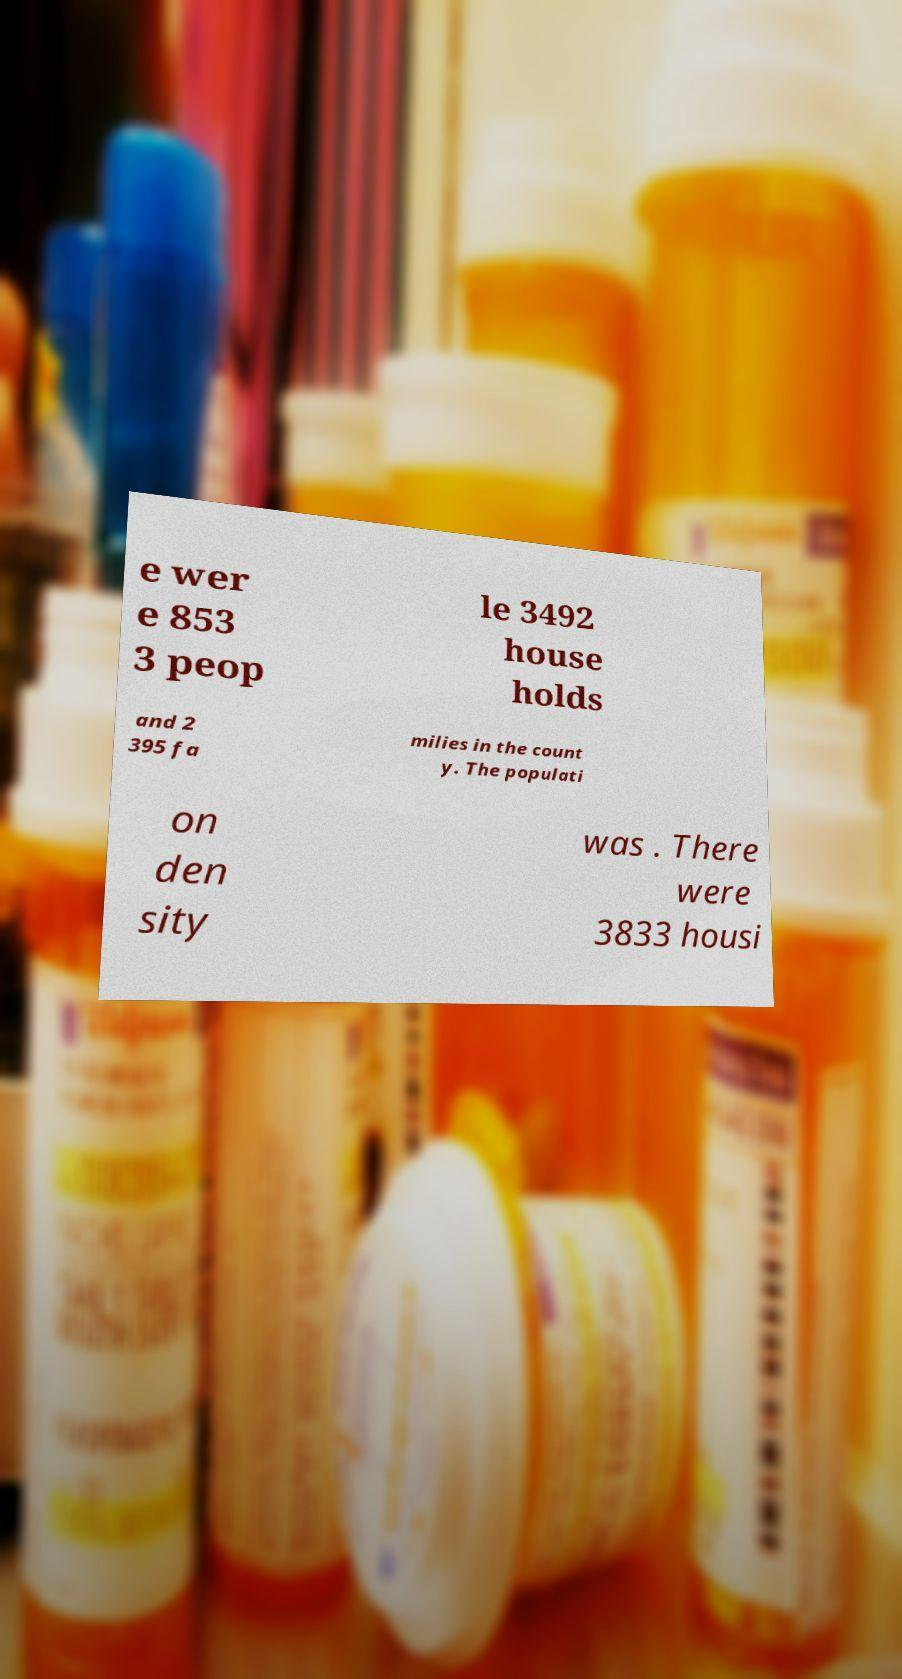There's text embedded in this image that I need extracted. Can you transcribe it verbatim? e wer e 853 3 peop le 3492 house holds and 2 395 fa milies in the count y. The populati on den sity was . There were 3833 housi 